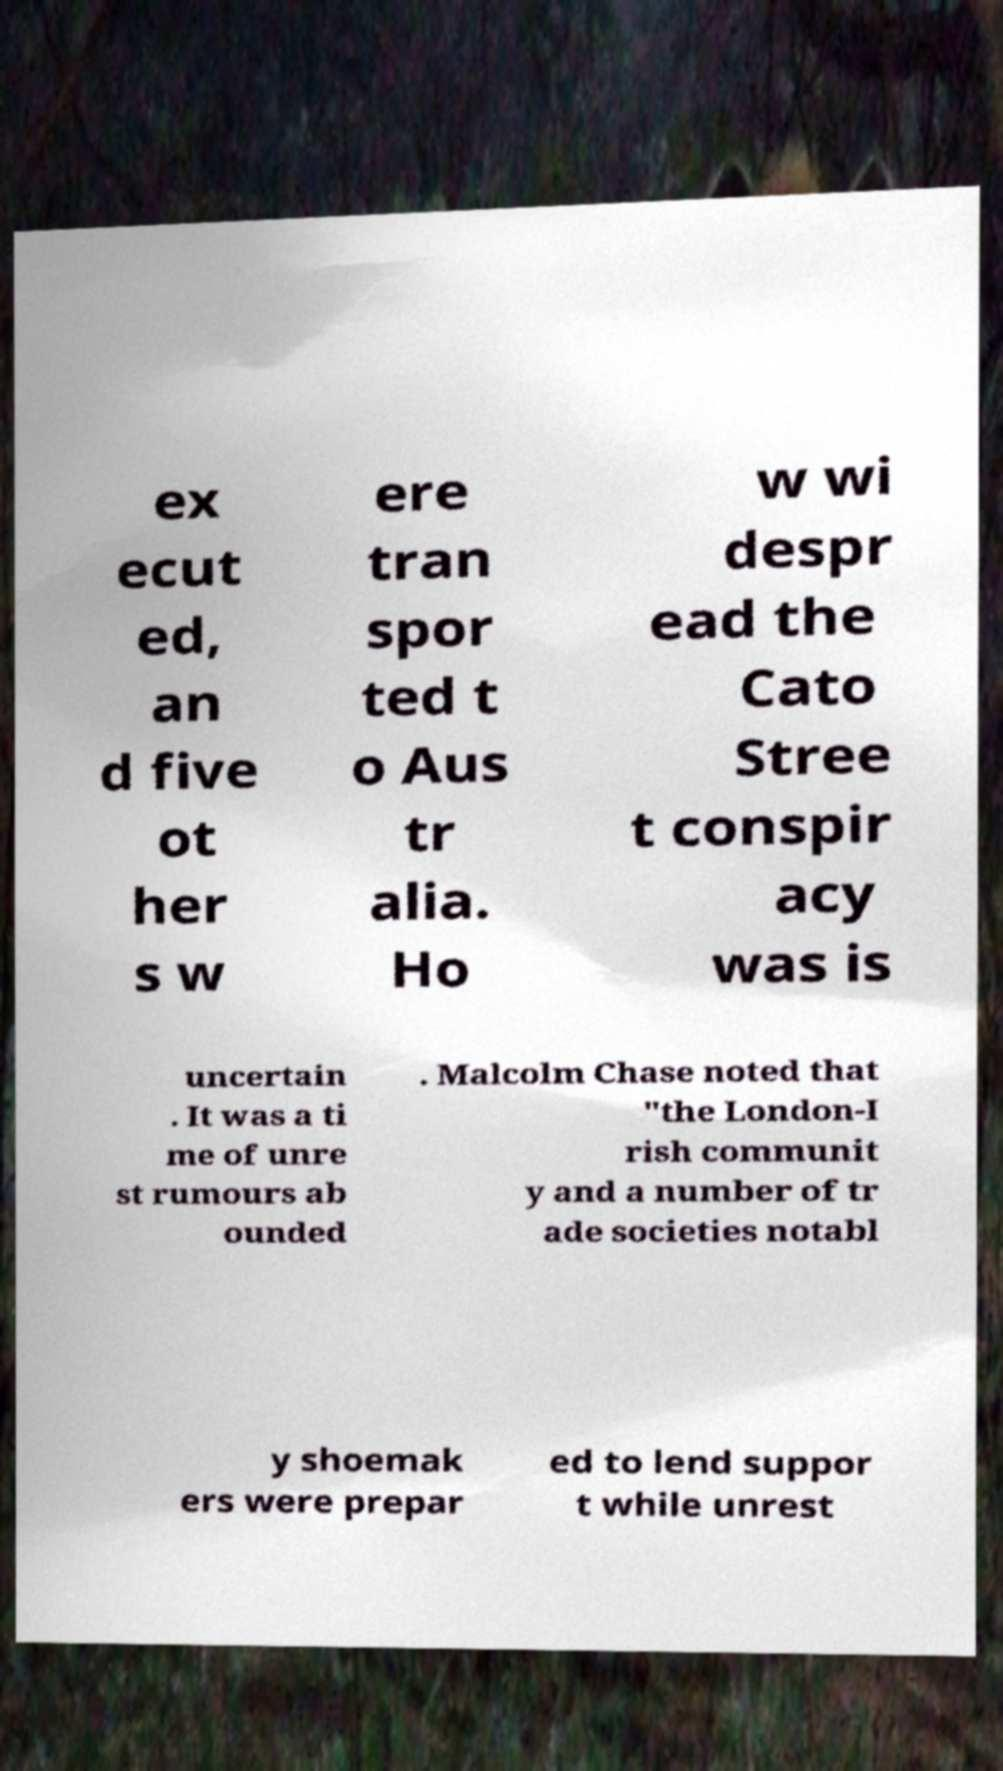There's text embedded in this image that I need extracted. Can you transcribe it verbatim? ex ecut ed, an d five ot her s w ere tran spor ted t o Aus tr alia. Ho w wi despr ead the Cato Stree t conspir acy was is uncertain . It was a ti me of unre st rumours ab ounded . Malcolm Chase noted that "the London-I rish communit y and a number of tr ade societies notabl y shoemak ers were prepar ed to lend suppor t while unrest 